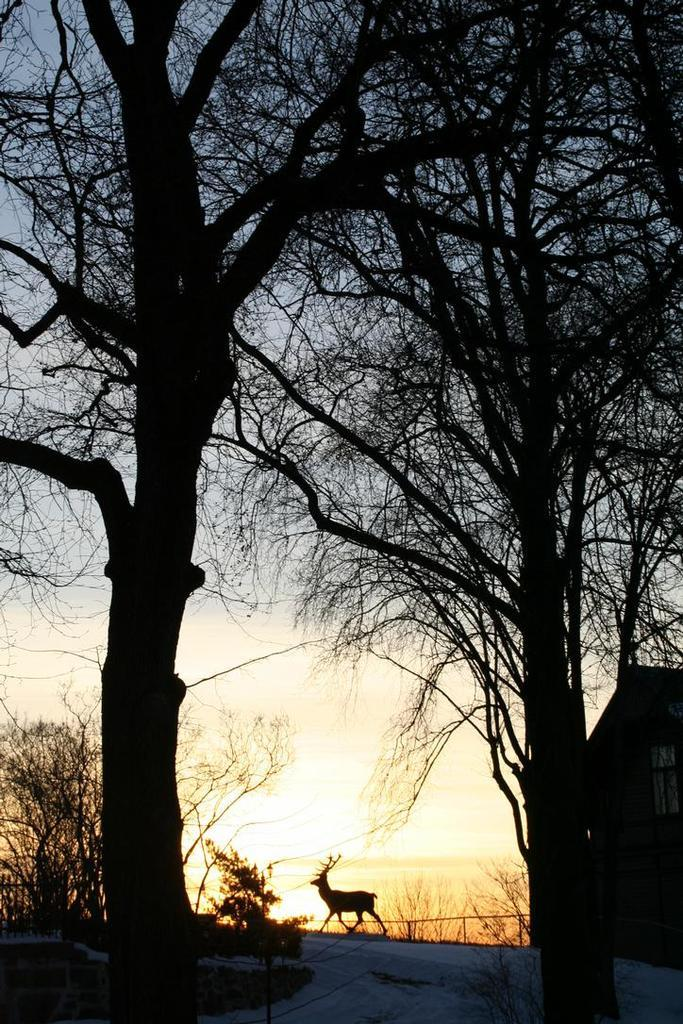What types of vegetation can be seen in the foreground of the picture? There are trees and plants in the foreground of the picture. What structures or objects are present in the foreground of the picture? There is a house, a road, and a railing in the foreground of the picture. Are there any animals visible in the foreground of the picture? Yes, there is an antelope in the foreground of the picture. What can be seen in the background of the picture? The sky is visible in the background of the picture. What type of pie is being served at the picnic in the picture? There is no picnic or pie present in the image; it features trees, plants, a house, a road, a railing, an antelope, and a sky. What color is the underwear of the person standing next to the antelope in the picture? There is no person or underwear present in the image; it only features trees, plants, a house, a road, a railing, and an antelope. 